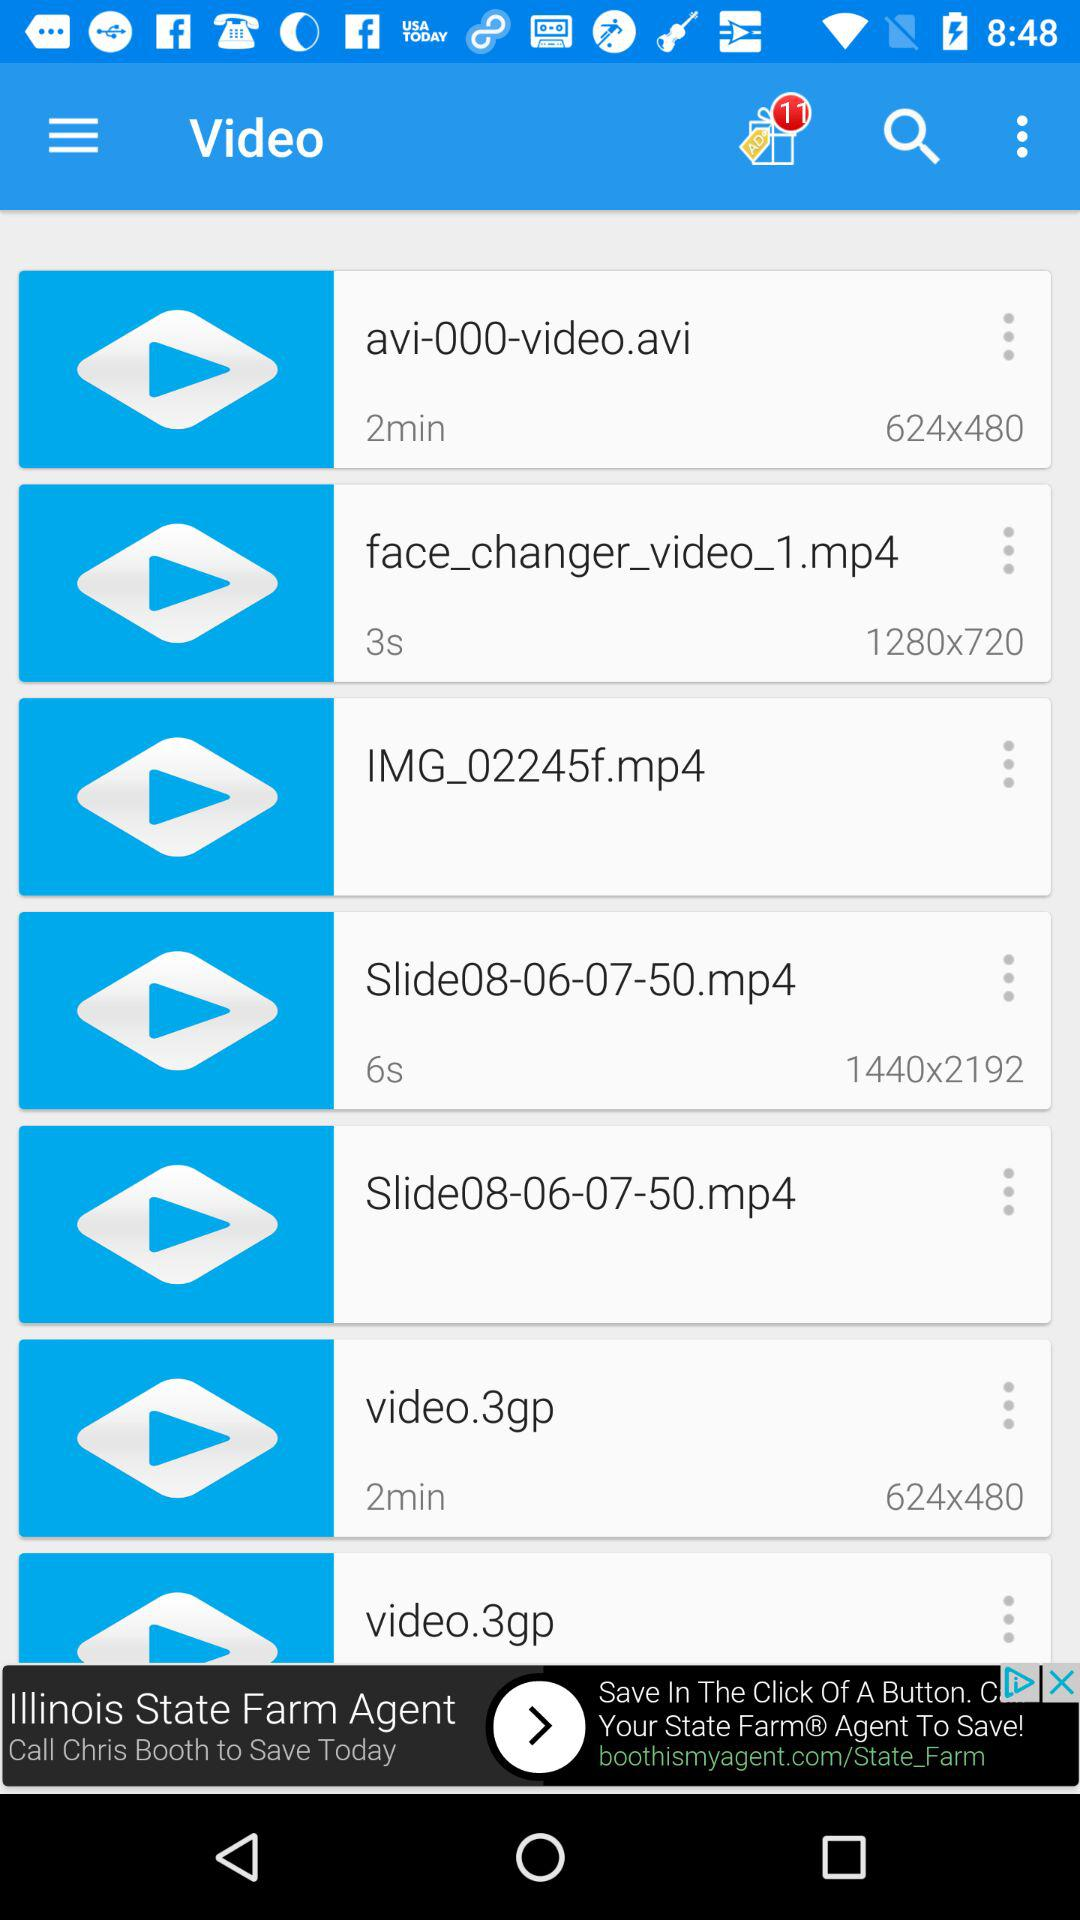How many unread notifications are there in this? There are 11 unread notifications. 